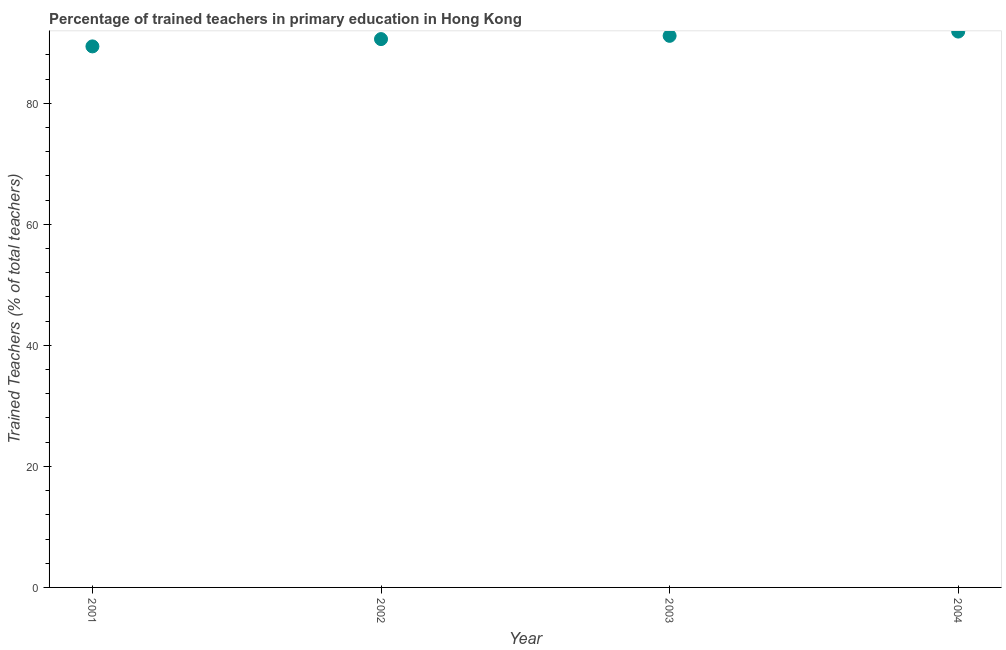What is the percentage of trained teachers in 2002?
Give a very brief answer. 90.61. Across all years, what is the maximum percentage of trained teachers?
Provide a short and direct response. 91.85. Across all years, what is the minimum percentage of trained teachers?
Offer a terse response. 89.4. In which year was the percentage of trained teachers maximum?
Provide a succinct answer. 2004. What is the sum of the percentage of trained teachers?
Provide a short and direct response. 363. What is the difference between the percentage of trained teachers in 2001 and 2003?
Your answer should be very brief. -1.74. What is the average percentage of trained teachers per year?
Provide a succinct answer. 90.75. What is the median percentage of trained teachers?
Offer a very short reply. 90.87. In how many years, is the percentage of trained teachers greater than 56 %?
Keep it short and to the point. 4. What is the ratio of the percentage of trained teachers in 2001 to that in 2003?
Offer a very short reply. 0.98. Is the difference between the percentage of trained teachers in 2003 and 2004 greater than the difference between any two years?
Your response must be concise. No. What is the difference between the highest and the second highest percentage of trained teachers?
Offer a terse response. 0.71. Is the sum of the percentage of trained teachers in 2001 and 2004 greater than the maximum percentage of trained teachers across all years?
Provide a short and direct response. Yes. What is the difference between the highest and the lowest percentage of trained teachers?
Offer a terse response. 2.45. Are the values on the major ticks of Y-axis written in scientific E-notation?
Your response must be concise. No. Does the graph contain grids?
Give a very brief answer. No. What is the title of the graph?
Your answer should be compact. Percentage of trained teachers in primary education in Hong Kong. What is the label or title of the X-axis?
Provide a short and direct response. Year. What is the label or title of the Y-axis?
Your answer should be compact. Trained Teachers (% of total teachers). What is the Trained Teachers (% of total teachers) in 2001?
Make the answer very short. 89.4. What is the Trained Teachers (% of total teachers) in 2002?
Provide a short and direct response. 90.61. What is the Trained Teachers (% of total teachers) in 2003?
Your response must be concise. 91.14. What is the Trained Teachers (% of total teachers) in 2004?
Your answer should be very brief. 91.85. What is the difference between the Trained Teachers (% of total teachers) in 2001 and 2002?
Your response must be concise. -1.21. What is the difference between the Trained Teachers (% of total teachers) in 2001 and 2003?
Keep it short and to the point. -1.74. What is the difference between the Trained Teachers (% of total teachers) in 2001 and 2004?
Make the answer very short. -2.45. What is the difference between the Trained Teachers (% of total teachers) in 2002 and 2003?
Offer a very short reply. -0.54. What is the difference between the Trained Teachers (% of total teachers) in 2002 and 2004?
Offer a terse response. -1.24. What is the difference between the Trained Teachers (% of total teachers) in 2003 and 2004?
Provide a short and direct response. -0.71. What is the ratio of the Trained Teachers (% of total teachers) in 2001 to that in 2003?
Your answer should be compact. 0.98. What is the ratio of the Trained Teachers (% of total teachers) in 2002 to that in 2004?
Provide a short and direct response. 0.99. What is the ratio of the Trained Teachers (% of total teachers) in 2003 to that in 2004?
Provide a short and direct response. 0.99. 